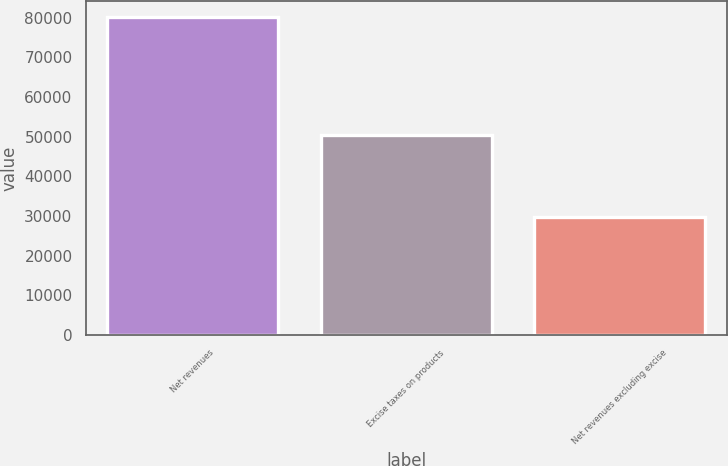Convert chart. <chart><loc_0><loc_0><loc_500><loc_500><bar_chart><fcel>Net revenues<fcel>Excise taxes on products<fcel>Net revenues excluding excise<nl><fcel>80106<fcel>50339<fcel>29767<nl></chart> 